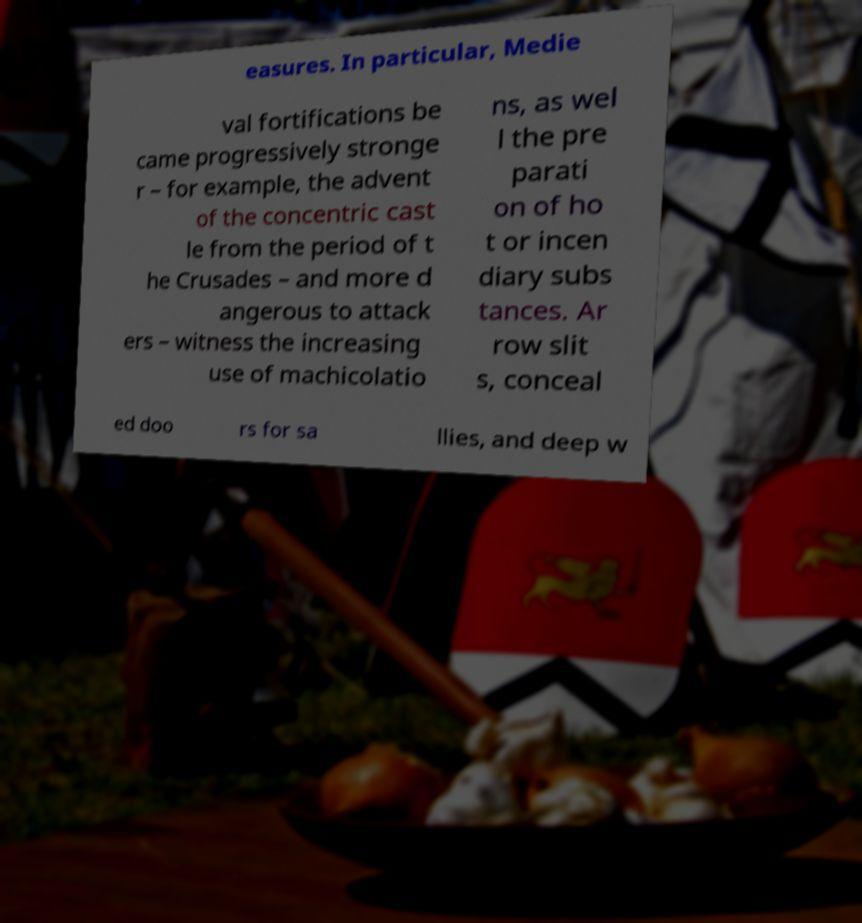Please identify and transcribe the text found in this image. easures. In particular, Medie val fortifications be came progressively stronge r – for example, the advent of the concentric cast le from the period of t he Crusades – and more d angerous to attack ers – witness the increasing use of machicolatio ns, as wel l the pre parati on of ho t or incen diary subs tances. Ar row slit s, conceal ed doo rs for sa llies, and deep w 